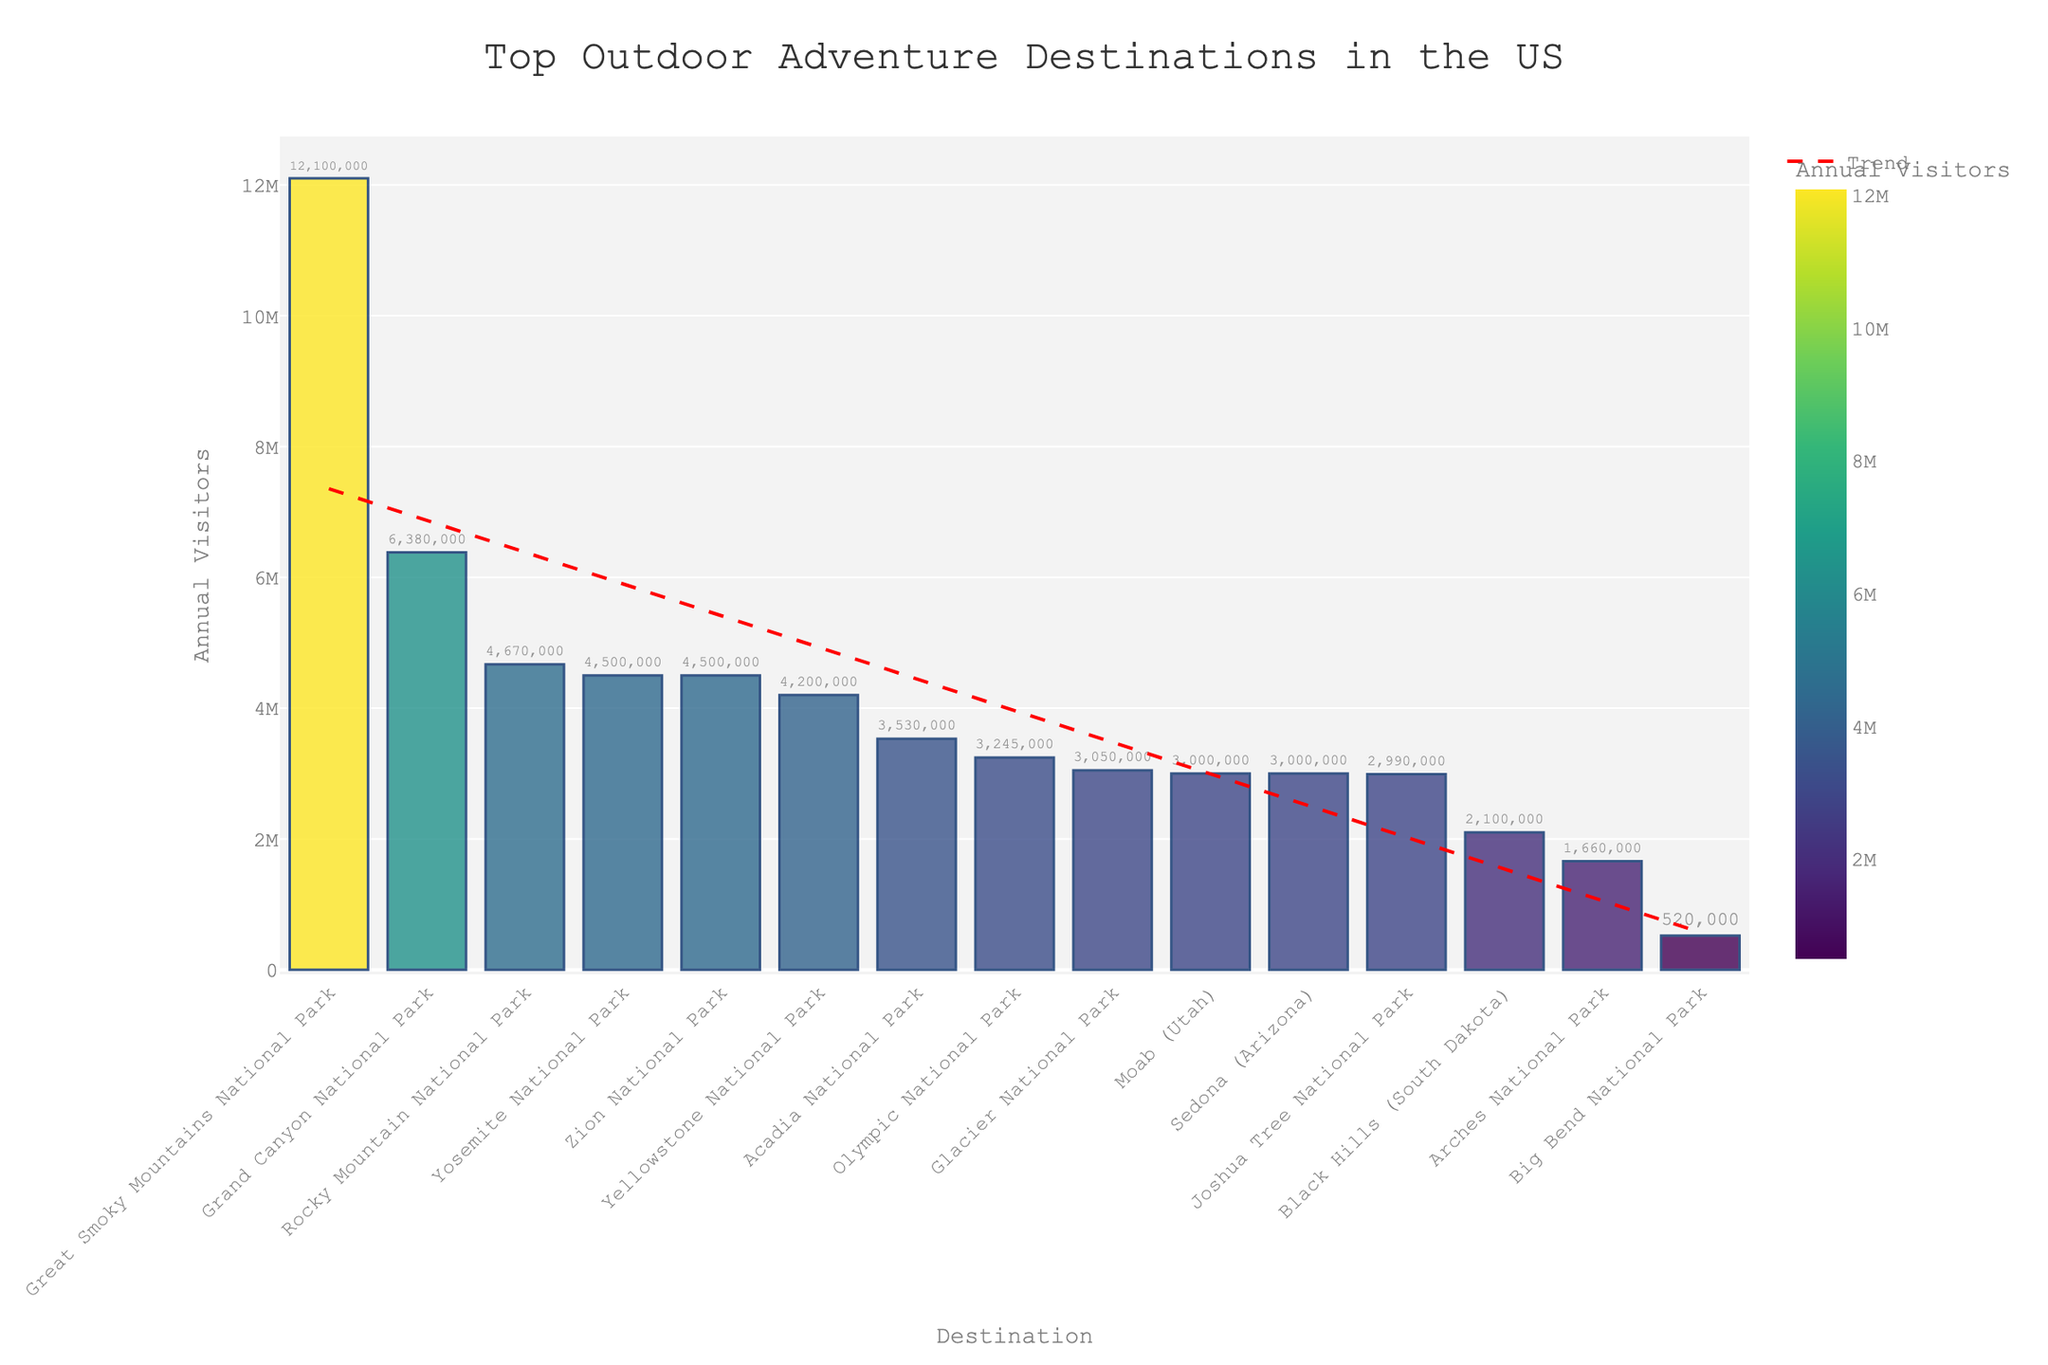What's the most visited outdoor adventure destination in the US? According to the bar chart, the Great Smoky Mountains National Park has the highest number of annual visitors.
Answer: Great Smoky Mountains National Park Which two destinations have the same number of annual visitors? By looking at the heights of the bars, Yellowstone National Park and Zion National Park both have the same number of annual visitors, each with 4,500,000.
Answer: Yellowstone National Park and Zion National Park What's the difference in annual visitors between Yosemite National Park and Arches National Park? Yosemite National Park has 4,500,000 visitors and Arches National Park has 1,660,000. The difference is calculated as 4,500,000 - 1,660,000.
Answer: 2,840,000 Which national parks have annual visitors greater than 6,000,000? By observing the bar heights, Great Smoky Mountains National Park and Grand Canyon National Park both have more than 6,000,000 annual visitors.
Answer: Great Smoky Mountains National Park and Grand Canyon National Park What is the average number of annual visitors for Yosemite, Zion, and Acadia National Parks? The number of visitors are 4,500,000, 4,500,000, and 3,530,000 respectively. The sum is 4,500,000 + 4,500,000 + 3,530,000 = 12,530,000. The average is 12,530,000 / 3.
Answer: 4,176,667 Rank the top three destinations by visitor numbers. The bar heights indicate that the Great Smoky Mountains National Park is first with 12,100,000 visitors, Grand Canyon National Park is second with 6,380,000 visitors, and Rocky Mountain National Park is third with 4,670,000 visitors.
Answer: Great Smoky Mountains National Park, Grand Canyon National Park, Rocky Mountain National Park How does the trend line visually compare to the bars? The red dashed trendline added to the chart roughly follows the decreasing height of the bars, indicating a downward trend in the number of annual visitors across the ranked destinations.
Answer: Downward trend What is the combined number of annual visitors for the three most popular national parks? Combining the visitors for Great Smoky Mountains (12,100,000), Grand Canyon (6,380,000), and Rocky Mountain National Park (4,670,000) gives 12,100,000 + 6,380,000 + 4,670,000.
Answer: 23,150,000 Which destination has just slightly fewer visitors than Glacier National Park? By comparing bar heights, Olympic National Park with 3,245,000 visitors has slightly fewer visitors than Glacier National Park, which has 3,050,000.
Answer: Olympic National Park What is the median number of annual visitors for all destinations listed? When the destinations are sorted by the number of visitors, the middle value (median) for this dataset is found to be the value of the 8th bar, which is Joshua Tree National Park with 2,990,000 visitors.
Answer: 2,990,000 